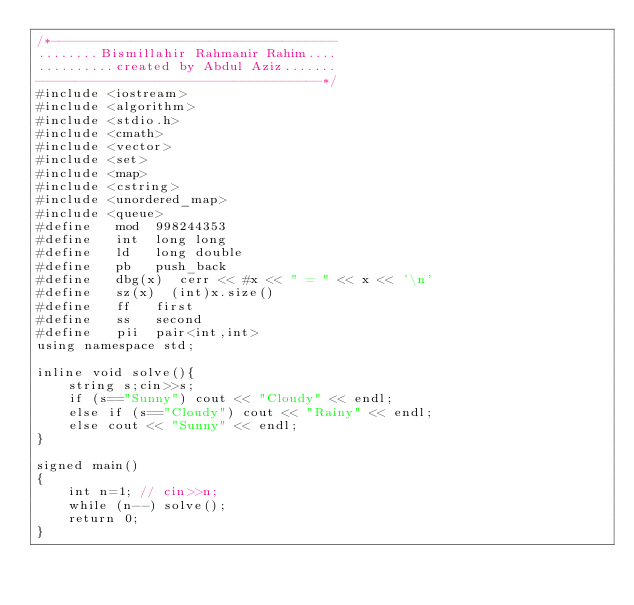<code> <loc_0><loc_0><loc_500><loc_500><_C++_>/*------------------------------------
........Bismillahir Rahmanir Rahim....
..........created by Abdul Aziz.......
------------------------------------*/
#include <iostream>
#include <algorithm>
#include <stdio.h>
#include <cmath>
#include <vector>
#include <set>
#include <map>
#include <cstring>
#include <unordered_map>
#include <queue>
#define   mod  998244353
#define   int  long long 
#define   ld   long double
#define   pb   push_back
#define   dbg(x)  cerr << #x << " = " << x << '\n'
#define   sz(x)  (int)x.size()
#define   ff   first
#define   ss   second
#define   pii  pair<int,int>
using namespace std;

inline void solve(){ 
    string s;cin>>s;
    if (s=="Sunny") cout << "Cloudy" << endl;
    else if (s=="Cloudy") cout << "Rainy" << endl;
    else cout << "Sunny" << endl;
}

signed main()
{
    int n=1; // cin>>n;
    while (n--) solve();
    return 0;
}
</code> 